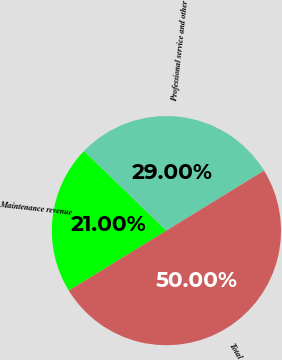<chart> <loc_0><loc_0><loc_500><loc_500><pie_chart><fcel>Maintenance revenue<fcel>Professional service and other<fcel>Total<nl><fcel>21.0%<fcel>29.0%<fcel>50.0%<nl></chart> 